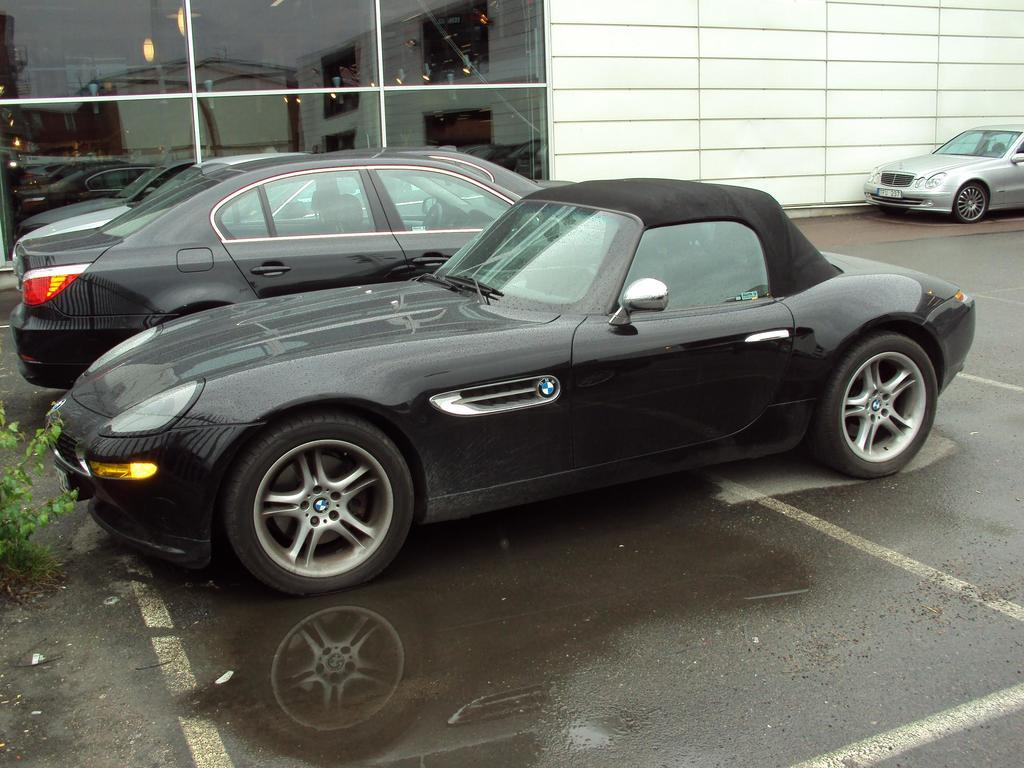How many cars are parked in the image? There are three cars parked in the image. What can be seen in the background of the image? There is a wall and a glass in the background of the image. Where are the leaves of a plant located in the image? The leaves of a plant are visible on the left side of the image. What type of pets are sitting on the cars in the image? There are no pets visible in the image; it only shows parked cars, a wall, a glass, and leaves of a plant. 